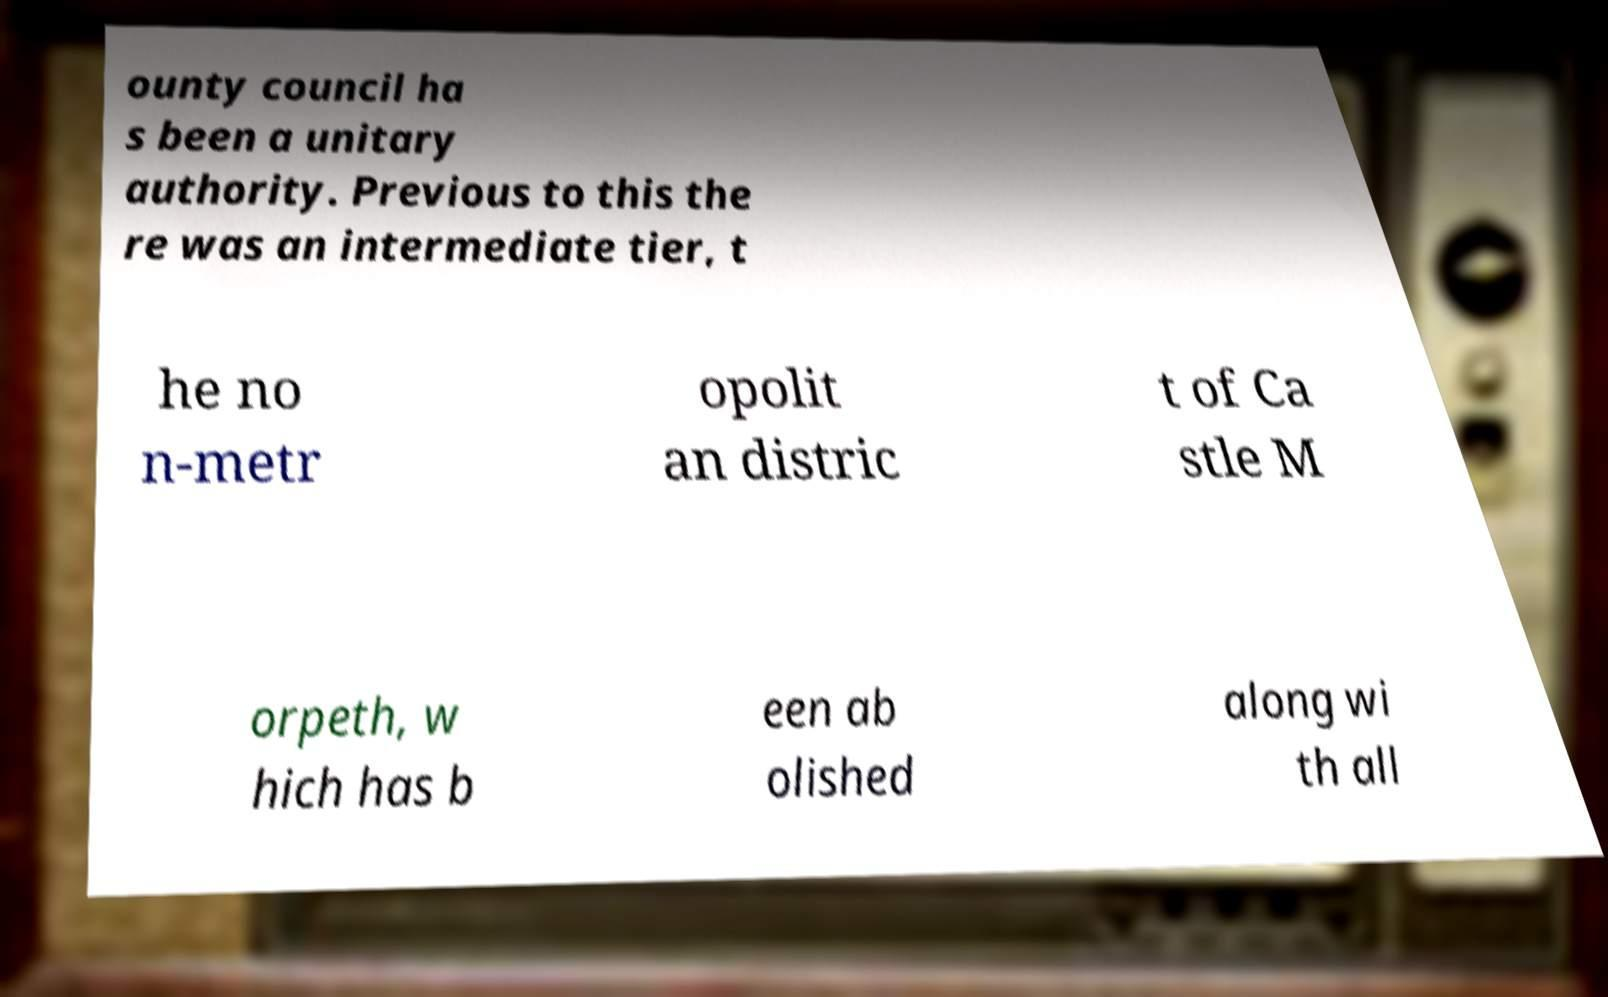Can you read and provide the text displayed in the image?This photo seems to have some interesting text. Can you extract and type it out for me? ounty council ha s been a unitary authority. Previous to this the re was an intermediate tier, t he no n-metr opolit an distric t of Ca stle M orpeth, w hich has b een ab olished along wi th all 